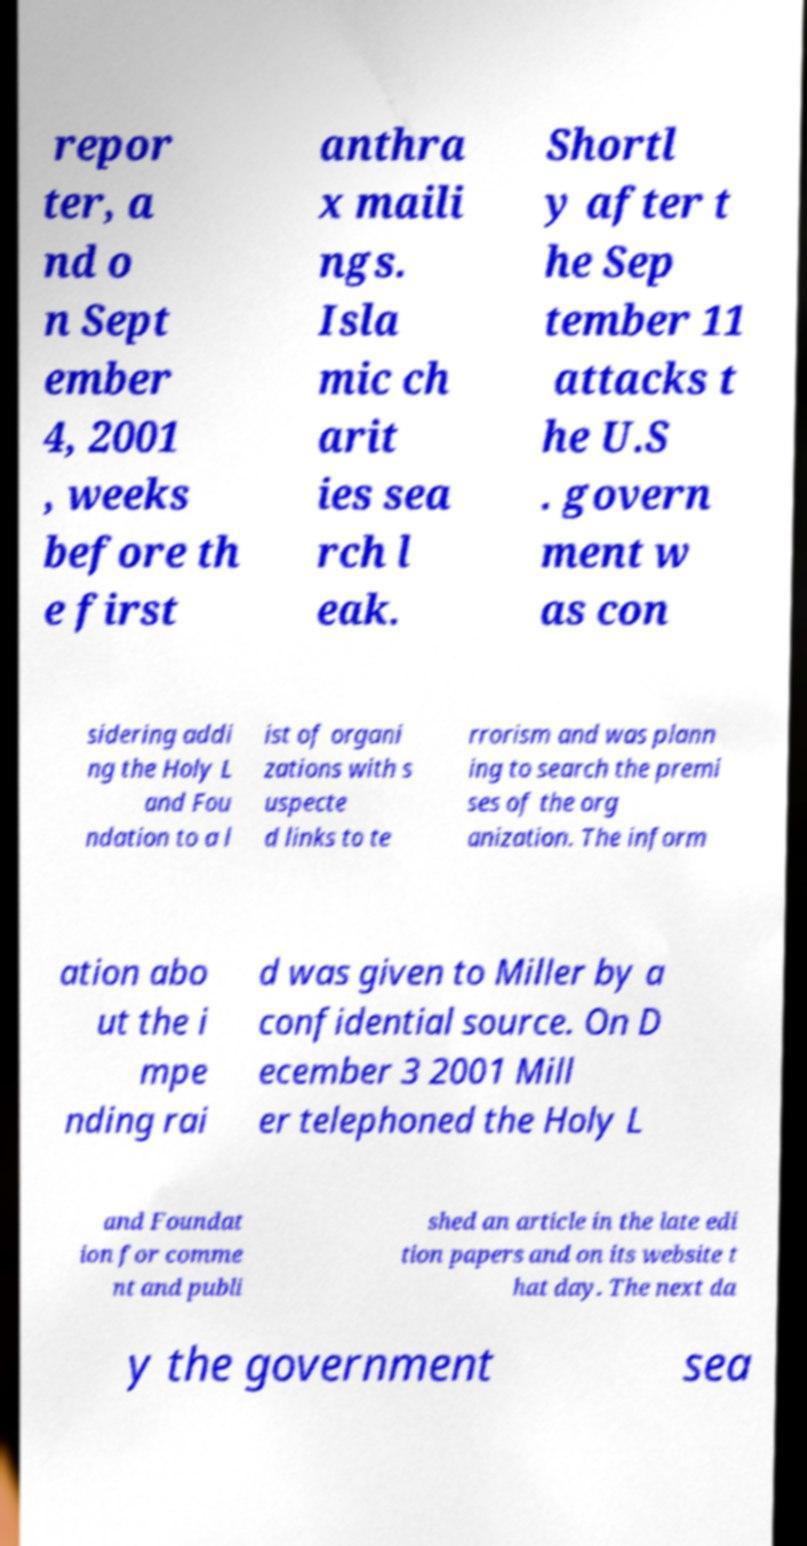Could you extract and type out the text from this image? repor ter, a nd o n Sept ember 4, 2001 , weeks before th e first anthra x maili ngs. Isla mic ch arit ies sea rch l eak. Shortl y after t he Sep tember 11 attacks t he U.S . govern ment w as con sidering addi ng the Holy L and Fou ndation to a l ist of organi zations with s uspecte d links to te rrorism and was plann ing to search the premi ses of the org anization. The inform ation abo ut the i mpe nding rai d was given to Miller by a confidential source. On D ecember 3 2001 Mill er telephoned the Holy L and Foundat ion for comme nt and publi shed an article in the late edi tion papers and on its website t hat day. The next da y the government sea 